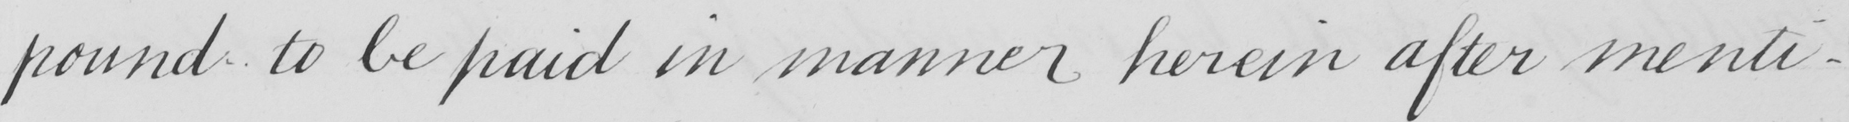Please transcribe the handwritten text in this image. pound to be paid in manner herein after menti- 